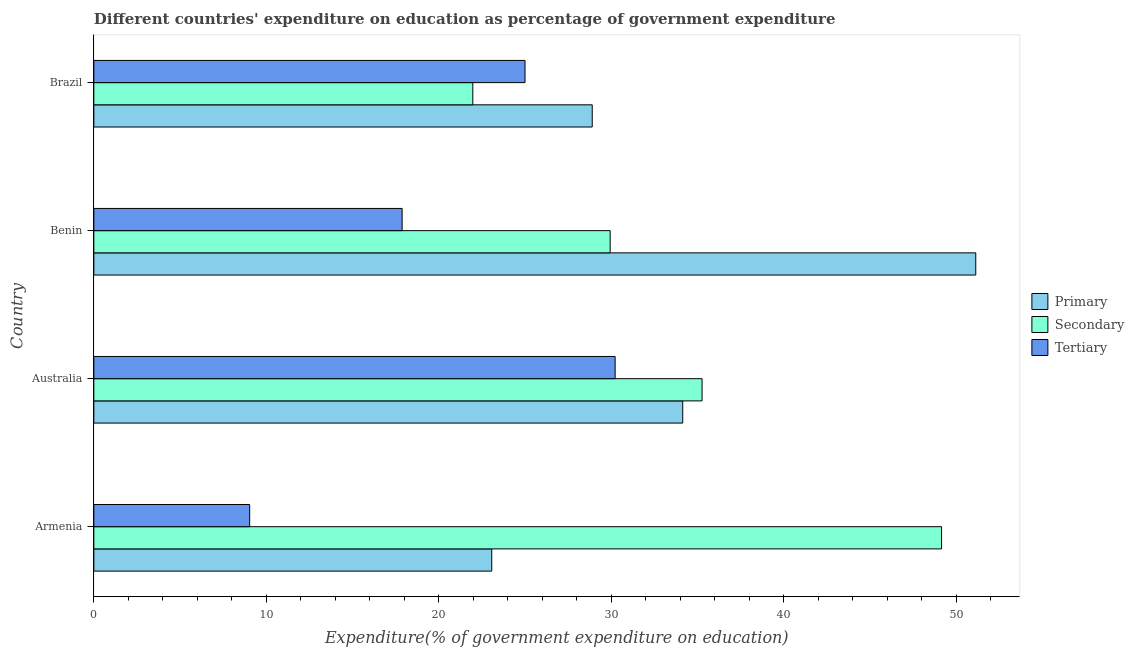How many different coloured bars are there?
Keep it short and to the point. 3. How many groups of bars are there?
Ensure brevity in your answer.  4. How many bars are there on the 2nd tick from the bottom?
Provide a succinct answer. 3. What is the label of the 1st group of bars from the top?
Your answer should be very brief. Brazil. What is the expenditure on tertiary education in Armenia?
Give a very brief answer. 9.03. Across all countries, what is the maximum expenditure on secondary education?
Your answer should be very brief. 49.15. Across all countries, what is the minimum expenditure on primary education?
Provide a succinct answer. 23.07. In which country was the expenditure on primary education minimum?
Offer a terse response. Armenia. What is the total expenditure on primary education in the graph?
Offer a terse response. 137.23. What is the difference between the expenditure on tertiary education in Armenia and that in Australia?
Your answer should be compact. -21.19. What is the difference between the expenditure on secondary education in Benin and the expenditure on tertiary education in Brazil?
Provide a succinct answer. 4.94. What is the average expenditure on tertiary education per country?
Offer a very short reply. 20.53. What is the difference between the expenditure on primary education and expenditure on secondary education in Australia?
Your answer should be very brief. -1.12. What is the ratio of the expenditure on primary education in Armenia to that in Brazil?
Ensure brevity in your answer.  0.8. Is the difference between the expenditure on primary education in Australia and Benin greater than the difference between the expenditure on secondary education in Australia and Benin?
Ensure brevity in your answer.  No. What is the difference between the highest and the second highest expenditure on primary education?
Ensure brevity in your answer.  16.99. What is the difference between the highest and the lowest expenditure on tertiary education?
Keep it short and to the point. 21.19. Is the sum of the expenditure on secondary education in Armenia and Australia greater than the maximum expenditure on tertiary education across all countries?
Keep it short and to the point. Yes. What does the 1st bar from the top in Benin represents?
Your response must be concise. Tertiary. What does the 3rd bar from the bottom in Brazil represents?
Provide a succinct answer. Tertiary. Is it the case that in every country, the sum of the expenditure on primary education and expenditure on secondary education is greater than the expenditure on tertiary education?
Keep it short and to the point. Yes. Are all the bars in the graph horizontal?
Your answer should be compact. Yes. What is the difference between two consecutive major ticks on the X-axis?
Your response must be concise. 10. Are the values on the major ticks of X-axis written in scientific E-notation?
Your answer should be compact. No. Does the graph contain any zero values?
Your answer should be very brief. No. Does the graph contain grids?
Your answer should be compact. No. How are the legend labels stacked?
Ensure brevity in your answer.  Vertical. What is the title of the graph?
Your answer should be very brief. Different countries' expenditure on education as percentage of government expenditure. What is the label or title of the X-axis?
Your answer should be compact. Expenditure(% of government expenditure on education). What is the label or title of the Y-axis?
Your answer should be very brief. Country. What is the Expenditure(% of government expenditure on education) in Primary in Armenia?
Provide a short and direct response. 23.07. What is the Expenditure(% of government expenditure on education) of Secondary in Armenia?
Make the answer very short. 49.15. What is the Expenditure(% of government expenditure on education) in Tertiary in Armenia?
Give a very brief answer. 9.03. What is the Expenditure(% of government expenditure on education) of Primary in Australia?
Give a very brief answer. 34.14. What is the Expenditure(% of government expenditure on education) in Secondary in Australia?
Ensure brevity in your answer.  35.26. What is the Expenditure(% of government expenditure on education) of Tertiary in Australia?
Provide a short and direct response. 30.22. What is the Expenditure(% of government expenditure on education) of Primary in Benin?
Ensure brevity in your answer.  51.13. What is the Expenditure(% of government expenditure on education) of Secondary in Benin?
Keep it short and to the point. 29.93. What is the Expenditure(% of government expenditure on education) of Tertiary in Benin?
Keep it short and to the point. 17.87. What is the Expenditure(% of government expenditure on education) in Primary in Brazil?
Give a very brief answer. 28.89. What is the Expenditure(% of government expenditure on education) of Secondary in Brazil?
Your answer should be very brief. 21.97. What is the Expenditure(% of government expenditure on education) in Tertiary in Brazil?
Offer a very short reply. 25. Across all countries, what is the maximum Expenditure(% of government expenditure on education) of Primary?
Make the answer very short. 51.13. Across all countries, what is the maximum Expenditure(% of government expenditure on education) of Secondary?
Offer a very short reply. 49.15. Across all countries, what is the maximum Expenditure(% of government expenditure on education) of Tertiary?
Offer a very short reply. 30.22. Across all countries, what is the minimum Expenditure(% of government expenditure on education) in Primary?
Keep it short and to the point. 23.07. Across all countries, what is the minimum Expenditure(% of government expenditure on education) of Secondary?
Make the answer very short. 21.97. Across all countries, what is the minimum Expenditure(% of government expenditure on education) of Tertiary?
Offer a terse response. 9.03. What is the total Expenditure(% of government expenditure on education) of Primary in the graph?
Make the answer very short. 137.23. What is the total Expenditure(% of government expenditure on education) of Secondary in the graph?
Give a very brief answer. 136.31. What is the total Expenditure(% of government expenditure on education) of Tertiary in the graph?
Your answer should be very brief. 82.13. What is the difference between the Expenditure(% of government expenditure on education) in Primary in Armenia and that in Australia?
Offer a very short reply. -11.07. What is the difference between the Expenditure(% of government expenditure on education) of Secondary in Armenia and that in Australia?
Your response must be concise. 13.89. What is the difference between the Expenditure(% of government expenditure on education) of Tertiary in Armenia and that in Australia?
Make the answer very short. -21.19. What is the difference between the Expenditure(% of government expenditure on education) of Primary in Armenia and that in Benin?
Give a very brief answer. -28.06. What is the difference between the Expenditure(% of government expenditure on education) in Secondary in Armenia and that in Benin?
Give a very brief answer. 19.21. What is the difference between the Expenditure(% of government expenditure on education) in Tertiary in Armenia and that in Benin?
Offer a very short reply. -8.84. What is the difference between the Expenditure(% of government expenditure on education) of Primary in Armenia and that in Brazil?
Give a very brief answer. -5.83. What is the difference between the Expenditure(% of government expenditure on education) in Secondary in Armenia and that in Brazil?
Provide a short and direct response. 27.18. What is the difference between the Expenditure(% of government expenditure on education) of Tertiary in Armenia and that in Brazil?
Give a very brief answer. -15.96. What is the difference between the Expenditure(% of government expenditure on education) of Primary in Australia and that in Benin?
Give a very brief answer. -16.99. What is the difference between the Expenditure(% of government expenditure on education) of Secondary in Australia and that in Benin?
Your answer should be compact. 5.33. What is the difference between the Expenditure(% of government expenditure on education) in Tertiary in Australia and that in Benin?
Your response must be concise. 12.35. What is the difference between the Expenditure(% of government expenditure on education) in Primary in Australia and that in Brazil?
Give a very brief answer. 5.25. What is the difference between the Expenditure(% of government expenditure on education) of Secondary in Australia and that in Brazil?
Your answer should be very brief. 13.29. What is the difference between the Expenditure(% of government expenditure on education) of Tertiary in Australia and that in Brazil?
Your response must be concise. 5.22. What is the difference between the Expenditure(% of government expenditure on education) of Primary in Benin and that in Brazil?
Ensure brevity in your answer.  22.23. What is the difference between the Expenditure(% of government expenditure on education) in Secondary in Benin and that in Brazil?
Offer a terse response. 7.96. What is the difference between the Expenditure(% of government expenditure on education) of Tertiary in Benin and that in Brazil?
Give a very brief answer. -7.12. What is the difference between the Expenditure(% of government expenditure on education) of Primary in Armenia and the Expenditure(% of government expenditure on education) of Secondary in Australia?
Give a very brief answer. -12.19. What is the difference between the Expenditure(% of government expenditure on education) of Primary in Armenia and the Expenditure(% of government expenditure on education) of Tertiary in Australia?
Your answer should be very brief. -7.15. What is the difference between the Expenditure(% of government expenditure on education) of Secondary in Armenia and the Expenditure(% of government expenditure on education) of Tertiary in Australia?
Offer a terse response. 18.92. What is the difference between the Expenditure(% of government expenditure on education) in Primary in Armenia and the Expenditure(% of government expenditure on education) in Secondary in Benin?
Offer a terse response. -6.86. What is the difference between the Expenditure(% of government expenditure on education) in Primary in Armenia and the Expenditure(% of government expenditure on education) in Tertiary in Benin?
Your response must be concise. 5.2. What is the difference between the Expenditure(% of government expenditure on education) of Secondary in Armenia and the Expenditure(% of government expenditure on education) of Tertiary in Benin?
Your response must be concise. 31.27. What is the difference between the Expenditure(% of government expenditure on education) of Primary in Armenia and the Expenditure(% of government expenditure on education) of Secondary in Brazil?
Ensure brevity in your answer.  1.1. What is the difference between the Expenditure(% of government expenditure on education) of Primary in Armenia and the Expenditure(% of government expenditure on education) of Tertiary in Brazil?
Provide a short and direct response. -1.93. What is the difference between the Expenditure(% of government expenditure on education) in Secondary in Armenia and the Expenditure(% of government expenditure on education) in Tertiary in Brazil?
Offer a very short reply. 24.15. What is the difference between the Expenditure(% of government expenditure on education) in Primary in Australia and the Expenditure(% of government expenditure on education) in Secondary in Benin?
Keep it short and to the point. 4.21. What is the difference between the Expenditure(% of government expenditure on education) in Primary in Australia and the Expenditure(% of government expenditure on education) in Tertiary in Benin?
Your answer should be compact. 16.27. What is the difference between the Expenditure(% of government expenditure on education) in Secondary in Australia and the Expenditure(% of government expenditure on education) in Tertiary in Benin?
Your answer should be very brief. 17.39. What is the difference between the Expenditure(% of government expenditure on education) in Primary in Australia and the Expenditure(% of government expenditure on education) in Secondary in Brazil?
Your answer should be compact. 12.17. What is the difference between the Expenditure(% of government expenditure on education) of Primary in Australia and the Expenditure(% of government expenditure on education) of Tertiary in Brazil?
Your response must be concise. 9.14. What is the difference between the Expenditure(% of government expenditure on education) of Secondary in Australia and the Expenditure(% of government expenditure on education) of Tertiary in Brazil?
Offer a very short reply. 10.26. What is the difference between the Expenditure(% of government expenditure on education) in Primary in Benin and the Expenditure(% of government expenditure on education) in Secondary in Brazil?
Make the answer very short. 29.16. What is the difference between the Expenditure(% of government expenditure on education) in Primary in Benin and the Expenditure(% of government expenditure on education) in Tertiary in Brazil?
Your answer should be compact. 26.13. What is the difference between the Expenditure(% of government expenditure on education) in Secondary in Benin and the Expenditure(% of government expenditure on education) in Tertiary in Brazil?
Give a very brief answer. 4.94. What is the average Expenditure(% of government expenditure on education) in Primary per country?
Offer a terse response. 34.31. What is the average Expenditure(% of government expenditure on education) of Secondary per country?
Give a very brief answer. 34.08. What is the average Expenditure(% of government expenditure on education) in Tertiary per country?
Your answer should be very brief. 20.53. What is the difference between the Expenditure(% of government expenditure on education) in Primary and Expenditure(% of government expenditure on education) in Secondary in Armenia?
Your answer should be compact. -26.08. What is the difference between the Expenditure(% of government expenditure on education) in Primary and Expenditure(% of government expenditure on education) in Tertiary in Armenia?
Ensure brevity in your answer.  14.04. What is the difference between the Expenditure(% of government expenditure on education) in Secondary and Expenditure(% of government expenditure on education) in Tertiary in Armenia?
Ensure brevity in your answer.  40.11. What is the difference between the Expenditure(% of government expenditure on education) in Primary and Expenditure(% of government expenditure on education) in Secondary in Australia?
Give a very brief answer. -1.12. What is the difference between the Expenditure(% of government expenditure on education) of Primary and Expenditure(% of government expenditure on education) of Tertiary in Australia?
Keep it short and to the point. 3.92. What is the difference between the Expenditure(% of government expenditure on education) of Secondary and Expenditure(% of government expenditure on education) of Tertiary in Australia?
Keep it short and to the point. 5.04. What is the difference between the Expenditure(% of government expenditure on education) of Primary and Expenditure(% of government expenditure on education) of Secondary in Benin?
Your answer should be compact. 21.2. What is the difference between the Expenditure(% of government expenditure on education) of Primary and Expenditure(% of government expenditure on education) of Tertiary in Benin?
Your answer should be compact. 33.26. What is the difference between the Expenditure(% of government expenditure on education) of Secondary and Expenditure(% of government expenditure on education) of Tertiary in Benin?
Give a very brief answer. 12.06. What is the difference between the Expenditure(% of government expenditure on education) in Primary and Expenditure(% of government expenditure on education) in Secondary in Brazil?
Your answer should be very brief. 6.92. What is the difference between the Expenditure(% of government expenditure on education) of Primary and Expenditure(% of government expenditure on education) of Tertiary in Brazil?
Give a very brief answer. 3.9. What is the difference between the Expenditure(% of government expenditure on education) of Secondary and Expenditure(% of government expenditure on education) of Tertiary in Brazil?
Provide a short and direct response. -3.03. What is the ratio of the Expenditure(% of government expenditure on education) in Primary in Armenia to that in Australia?
Your answer should be very brief. 0.68. What is the ratio of the Expenditure(% of government expenditure on education) in Secondary in Armenia to that in Australia?
Provide a succinct answer. 1.39. What is the ratio of the Expenditure(% of government expenditure on education) of Tertiary in Armenia to that in Australia?
Give a very brief answer. 0.3. What is the ratio of the Expenditure(% of government expenditure on education) in Primary in Armenia to that in Benin?
Ensure brevity in your answer.  0.45. What is the ratio of the Expenditure(% of government expenditure on education) in Secondary in Armenia to that in Benin?
Offer a terse response. 1.64. What is the ratio of the Expenditure(% of government expenditure on education) in Tertiary in Armenia to that in Benin?
Offer a very short reply. 0.51. What is the ratio of the Expenditure(% of government expenditure on education) in Primary in Armenia to that in Brazil?
Provide a short and direct response. 0.8. What is the ratio of the Expenditure(% of government expenditure on education) in Secondary in Armenia to that in Brazil?
Provide a succinct answer. 2.24. What is the ratio of the Expenditure(% of government expenditure on education) in Tertiary in Armenia to that in Brazil?
Your answer should be compact. 0.36. What is the ratio of the Expenditure(% of government expenditure on education) of Primary in Australia to that in Benin?
Provide a succinct answer. 0.67. What is the ratio of the Expenditure(% of government expenditure on education) of Secondary in Australia to that in Benin?
Provide a short and direct response. 1.18. What is the ratio of the Expenditure(% of government expenditure on education) in Tertiary in Australia to that in Benin?
Ensure brevity in your answer.  1.69. What is the ratio of the Expenditure(% of government expenditure on education) in Primary in Australia to that in Brazil?
Ensure brevity in your answer.  1.18. What is the ratio of the Expenditure(% of government expenditure on education) of Secondary in Australia to that in Brazil?
Offer a very short reply. 1.6. What is the ratio of the Expenditure(% of government expenditure on education) in Tertiary in Australia to that in Brazil?
Provide a succinct answer. 1.21. What is the ratio of the Expenditure(% of government expenditure on education) of Primary in Benin to that in Brazil?
Provide a succinct answer. 1.77. What is the ratio of the Expenditure(% of government expenditure on education) of Secondary in Benin to that in Brazil?
Offer a very short reply. 1.36. What is the ratio of the Expenditure(% of government expenditure on education) of Tertiary in Benin to that in Brazil?
Keep it short and to the point. 0.71. What is the difference between the highest and the second highest Expenditure(% of government expenditure on education) in Primary?
Provide a short and direct response. 16.99. What is the difference between the highest and the second highest Expenditure(% of government expenditure on education) of Secondary?
Offer a very short reply. 13.89. What is the difference between the highest and the second highest Expenditure(% of government expenditure on education) of Tertiary?
Your answer should be very brief. 5.22. What is the difference between the highest and the lowest Expenditure(% of government expenditure on education) in Primary?
Offer a terse response. 28.06. What is the difference between the highest and the lowest Expenditure(% of government expenditure on education) in Secondary?
Offer a terse response. 27.18. What is the difference between the highest and the lowest Expenditure(% of government expenditure on education) of Tertiary?
Make the answer very short. 21.19. 